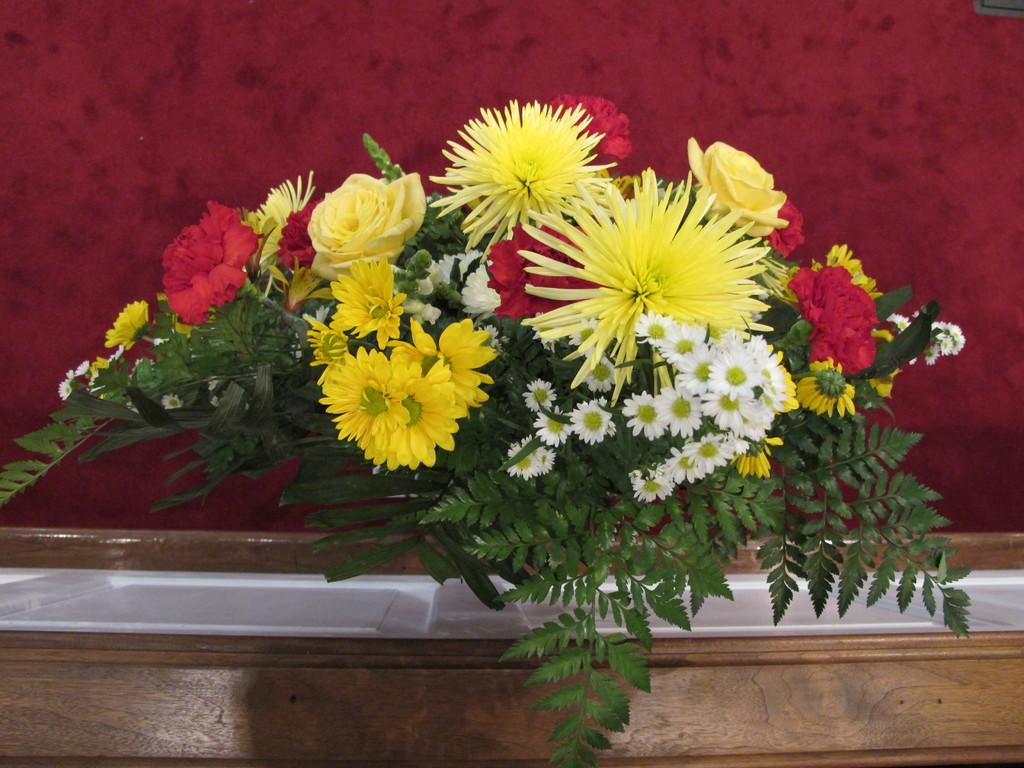What is the main subject of the image? There is a flower bouquet in the image. Where is the flower bouquet located? The flower bouquet is placed on a table. What is covering the table? There is a white color sheet on the table. What color is the background of the image? The background of the image is red in color. Where is the nearest store to purchase ice for the flower bouquet in the image? The image does not provide information about the location of a store or the need for ice for the flower bouquet. 